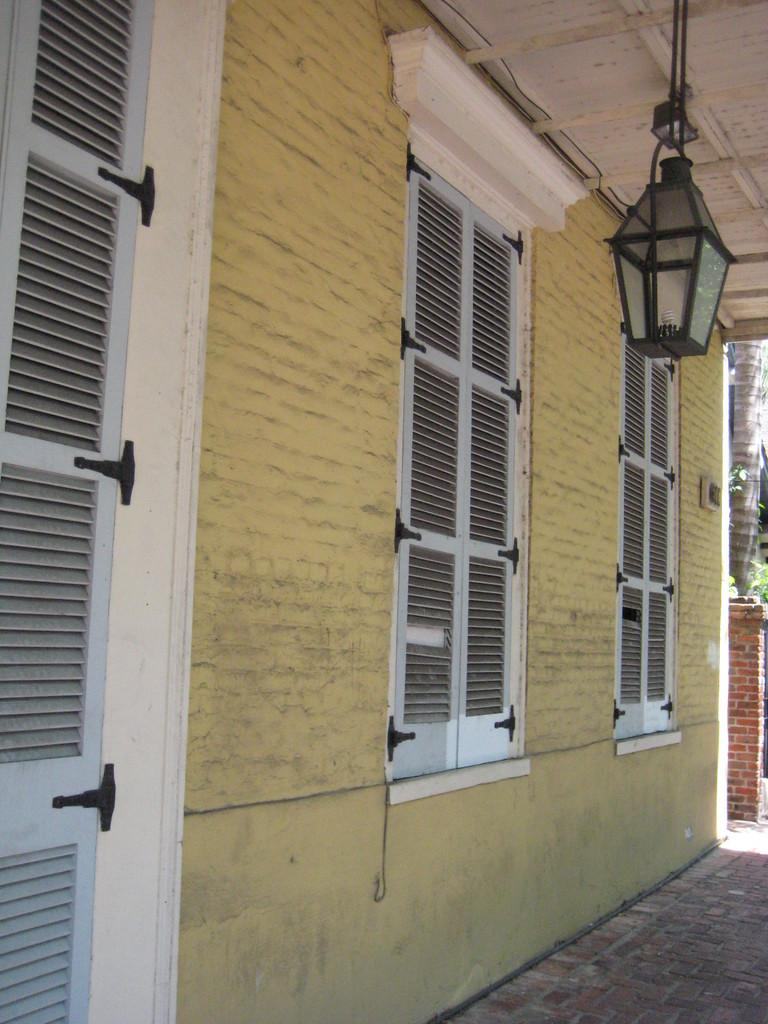What is the main subject in the center of the image? There is a building, a wall, a roof, a lamp, and window blinds in the center of the image. Can you describe the roof in the center of the image? The roof is part of the building in the center of the image. What is the purpose of the lamp in the center of the image? The lamp is likely for providing light in the building. What type of window covering is present in the center of the image? There are window blinds in the center of the image. Are there any other objects in the center of the image besides the building components? Yes, there are other objects in the center of the image. How does the digestion process work for the tree in the background of the image? There is no digestion process for the tree in the background of the image, as trees do not have a digestive system. What color are the toenails of the person standing next to the pillar in the background of the image? There is no person standing next to the pillar in the background of the image, so we cannot determine the color of their toenails. 